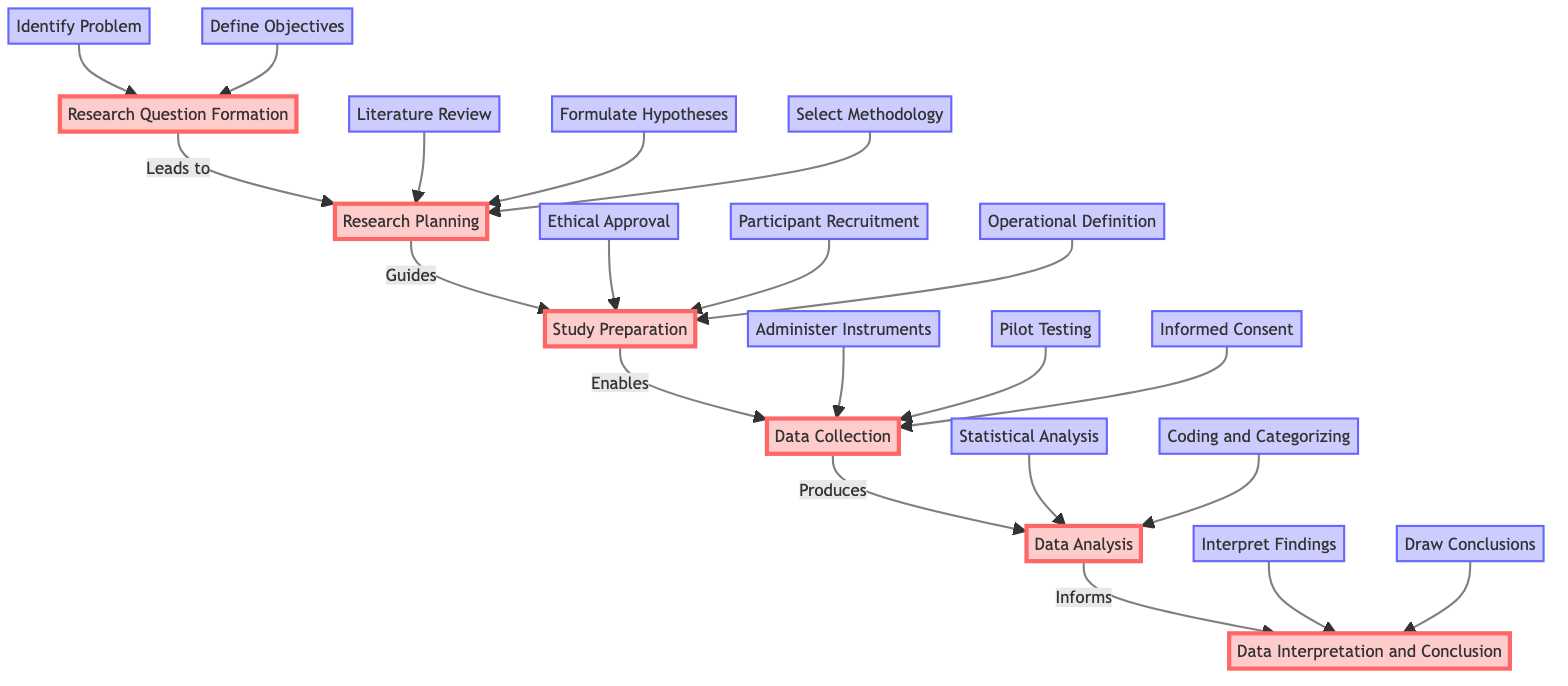What is the first step in research study design? The first step is "Research Question Formation," where specific psychological issues or topics are identified and objectives defined.
Answer: Research Question Formation How many main sections are in the flowchart? The flowchart consists of five main sections: Research Question Formation, Research Planning, Study Preparation, Data Collection, Data Analysis, and Data Interpretation and Conclusion.
Answer: Five Which section comes after Data Collection? The section that comes after Data Collection is Data Analysis, indicating that data collection produces data that is then analyzed.
Answer: Data Analysis What is linked directly to Data Interpretation and Conclusion? Data Interpretation and Conclusion is directly informed by Data Analysis, indicating that the findings are based on analyzed data.
Answer: Data Analysis What step involves defining variables in measurable terms? The step that involves defining variables in measurable terms is "Operational Definition," which occurs in the Study Preparation section.
Answer: Operational Definition How are hypotheses formulated in the study design process? Hypotheses are formulated during the Research Planning stage, following a literature review and the identification of a research gap.
Answer: Formulate Hypotheses Which step precedes administering instruments for data collection? The step that precedes administering instruments is "Informed Consent," which ensures participants are aware of the study’s nature before data collection.
Answer: Informed Consent Which section includes "Pilot Testing"? "Pilot Testing" is included in the Data Collection section, and it serves as a preliminary test to refine study procedures.
Answer: Data Collection In the flowchart, how does data analysis contribute to the research process? Data analysis informs the Data Interpretation and Conclusion section, linking analyzed data findings back to initial hypotheses and research questions, thus playing a crucial role in drawing conclusions.
Answer: Informs Data Interpretation and Conclusion 